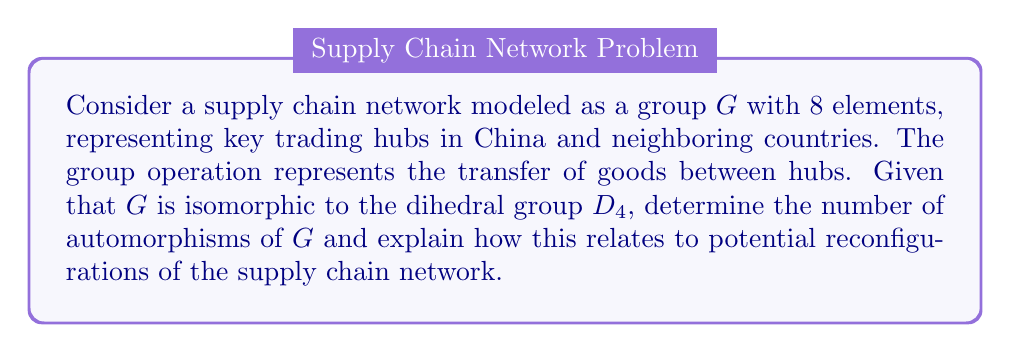Help me with this question. To solve this problem, we'll follow these steps:

1) First, recall that the dihedral group $D_4$ is the group of symmetries of a square. It has 8 elements: 4 rotations and 4 reflections.

2) The automorphism group of $D_4$ is isomorphic to the holomorph of $C_2 \times C_2$, which is $(C_2 \times C_2) \rtimes S_3$, where $S_3$ is the symmetric group on 3 elements.

3) To calculate the number of automorphisms, we need to determine the order of this group:

   $|Aut(D_4)| = |C_2 \times C_2| \cdot |S_3| = 4 \cdot 6 = 24$

4) Therefore, there are 24 automorphisms of $G$.

5) In the context of the supply chain network:
   - Each element of $G$ represents a trading hub.
   - Automorphisms represent ways to reconfigure the network while preserving its structure.
   - The 24 automorphisms indicate that there are 24 ways to reassign the roles of the hubs without changing the overall structure of the network.

6) This high number of automorphisms suggests flexibility in the supply chain network. It means that:
   - The network can be reorganized in many ways without fundamentally altering its efficiency or connectivity.
   - There's potential for adapting to changing economic conditions or trade regulations by reassigning hub roles.
   - The network is resilient to disruptions, as there are multiple ways to reroute supply chains while maintaining the overall structure.

This analysis provides valuable insights for an entrepreneur involved in cross-border trade, as it demonstrates the adaptability and resilience of the modeled supply chain network.
Answer: The number of automorphisms of the group $G$ is 24. This indicates that there are 24 ways to reconfigure the supply chain network while preserving its structural properties, suggesting high flexibility and resilience in the trade network between China and its neighboring countries. 